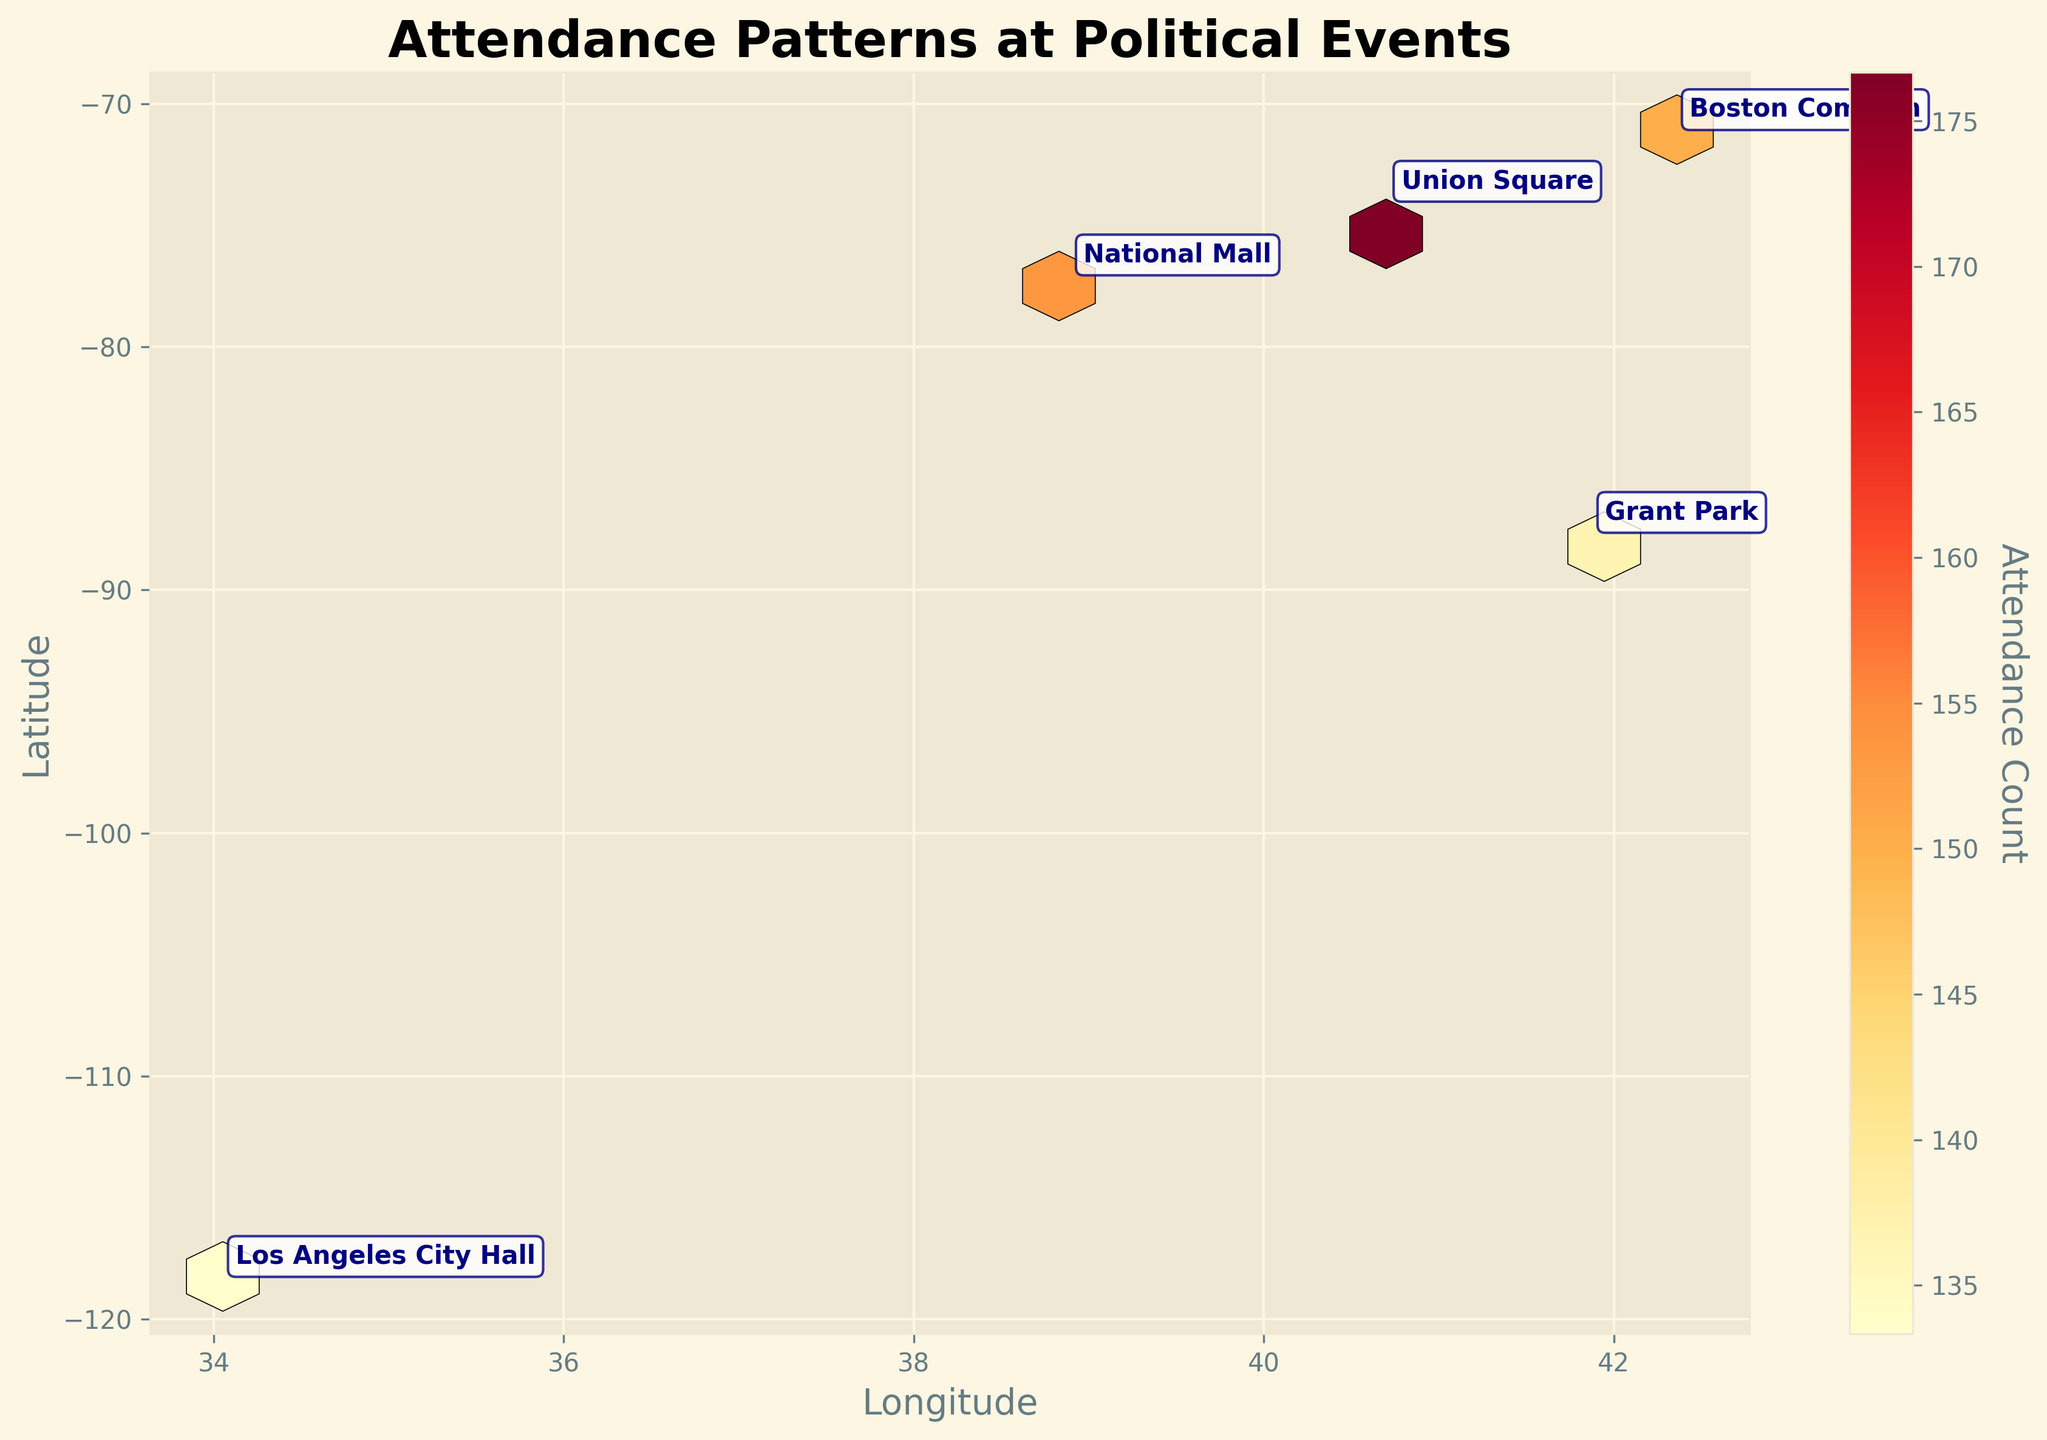What's the title of the figure? The title is given at the top of the figure and describes the content of the plot.
Answer: Attendance Patterns at Political Events What do the colors in the hexagons represent? The colors in the hexagons indicate the attendance counts, with a gradient from lighter to darker colors showing increasing values.
Answer: Attendance count Which location appears to have the highest attendance count? By observing the intensity of the colors, the location with the darkest hexagon will have the highest count.
Answer: Union Square Which demographic has the highest attendance at Los Angeles City Hall? The demographic with the highest attendance is indicated by the color intensity at Los Angeles City Hall. Verify which part has the darkest shade.
Answer: Middle-aged What's the common characteristic of annotations next to locations on the plot? Annotations describe the average positional values (longitude and latitude) and a name tag that shows the location. Each annotation is positioned near its respective location, with a detailed and noticeable border.
Answer: Average positional values and location name What is the median attendance count for young adults at the events? To find the median, list the counts for young adults: [150, 180, 160, 140, 130] and identify the middle value.
Answer: 150 How does the attendance count at Boston Common compare for young adults versus seniors? Compare the hexagon shades to identify numbers and subtract: young adults (150) - seniors (100).
Answer: 50 more for young adults Which city has the lowest senior attendance? By checking the color gradients for seniors across cities and identifying the lightest shade, you can determine the exact city.
Answer: Los Angeles City Hall In terms of geography, which city shows the highest diversity in attendance counts across different demographics? Examine the color variations of each demographic within cities and identify the city with the greatest spread of colors.
Answer: Union Square What's the overall trend in attendance patterns based on location and demographics? Summarize the color intensities and frequencies across locations and demographics to interpret patterns: young adults and middle-aged groups tend to have higher attendance, with Union Square showing the highest overall attendance.
Answer: Young adults & middle-aged higher, Union Square highest 